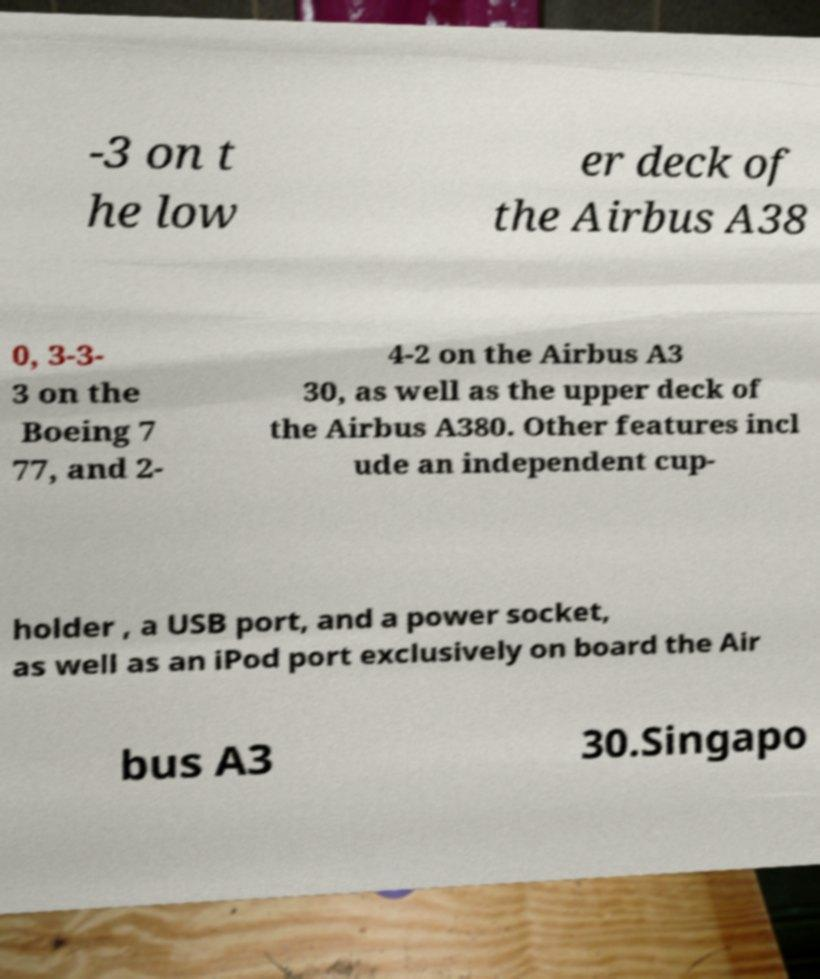Can you read and provide the text displayed in the image?This photo seems to have some interesting text. Can you extract and type it out for me? -3 on t he low er deck of the Airbus A38 0, 3-3- 3 on the Boeing 7 77, and 2- 4-2 on the Airbus A3 30, as well as the upper deck of the Airbus A380. Other features incl ude an independent cup- holder , a USB port, and a power socket, as well as an iPod port exclusively on board the Air bus A3 30.Singapo 